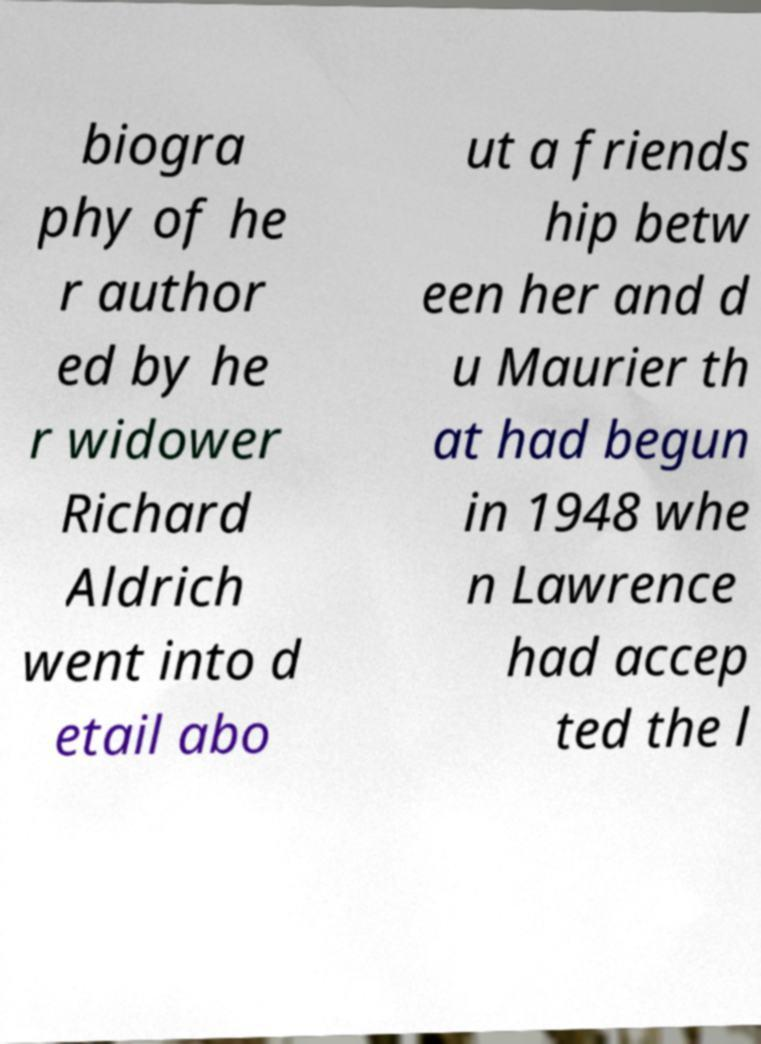I need the written content from this picture converted into text. Can you do that? biogra phy of he r author ed by he r widower Richard Aldrich went into d etail abo ut a friends hip betw een her and d u Maurier th at had begun in 1948 whe n Lawrence had accep ted the l 